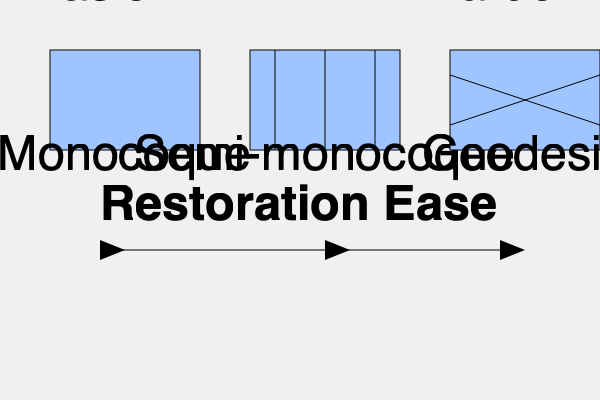Based on the structural complexity and accessibility of components, which type of aircraft fuselage structure would typically be the most challenging to restore? To determine which fuselage structure would be most challenging to restore, we need to consider the complexity and accessibility of each type:

1. Monocoque:
   - Simple, stress-bearing outer shell
   - Few internal components
   - Large, open interior spaces
   - Easier access for restoration

2. Semi-monocoque:
   - Stress-bearing outer shell with internal supports (stringers and formers)
   - More complex than monocoque, but still relatively straightforward
   - Moderate accessibility for restoration

3. Geodesic:
   - Complex lattice of intersecting diagonal members
   - Highly intricate internal structure
   - Difficult to access individual components
   - Challenging to replace or repair specific elements without affecting others

Considering these factors, the geodesic structure presents the most challenges for restoration due to its complexity and the interdependence of its components. The intricate lattice makes it difficult to access, repair, or replace individual elements without potentially compromising the structural integrity of surrounding areas.

The monocoque structure would be the easiest to restore, followed by the semi-monocoque, with the geodesic being the most challenging.
Answer: Geodesic 